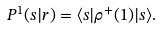Convert formula to latex. <formula><loc_0><loc_0><loc_500><loc_500>P ^ { 1 } ( s | r ) = \langle s | \rho ^ { + } ( 1 ) | s \rangle .</formula> 